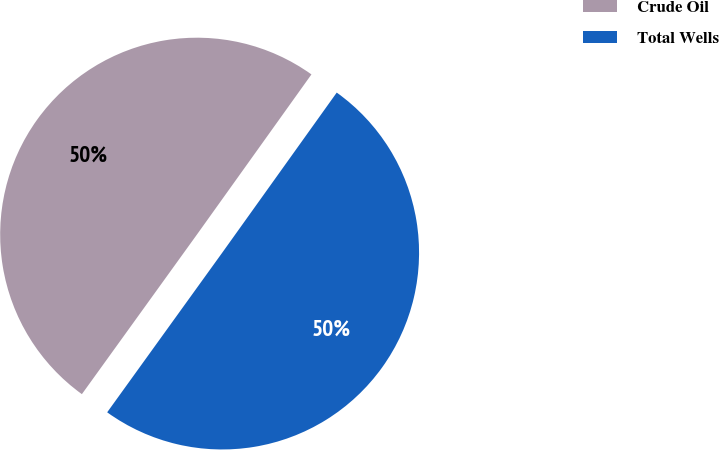Convert chart. <chart><loc_0><loc_0><loc_500><loc_500><pie_chart><fcel>Crude Oil<fcel>Total Wells<nl><fcel>49.94%<fcel>50.06%<nl></chart> 